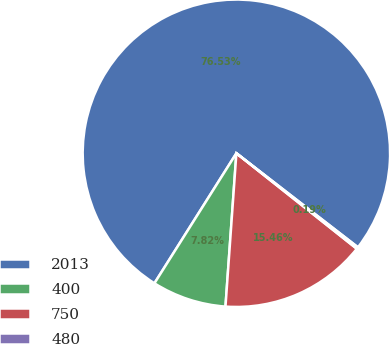<chart> <loc_0><loc_0><loc_500><loc_500><pie_chart><fcel>2013<fcel>400<fcel>750<fcel>480<nl><fcel>76.53%<fcel>7.82%<fcel>15.46%<fcel>0.19%<nl></chart> 